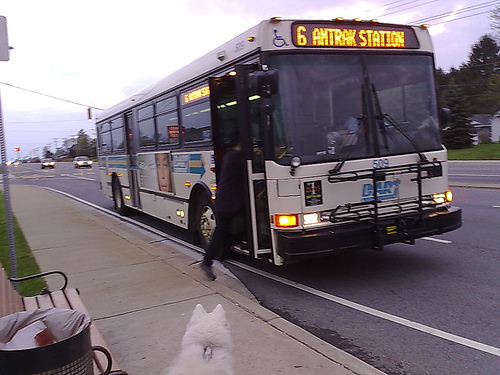Please provide a short description for this region: [0.01, 0.58, 0.21, 0.85]. In the region [0.01, 0.58, 0.21, 0.85], you can spot a common urban setup of a metal trash can standing closely next to a sturdy, functional bench, inviting a brief respite for passersby. 